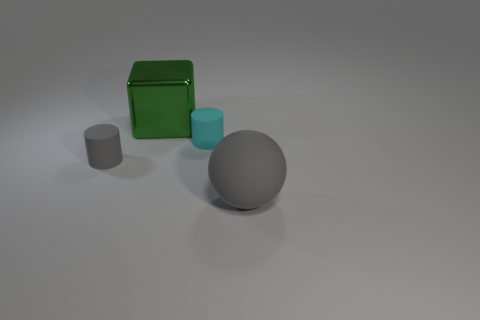How could the arrangement of these objects be described in terms of composition? The objects are arranged asymmetrically. The green box and the small gray cylinder form a cluster to the left, while the large gray sphere and the cyan cylinder are slightly isolated from the rest, creating a sense of balance in the composition. 